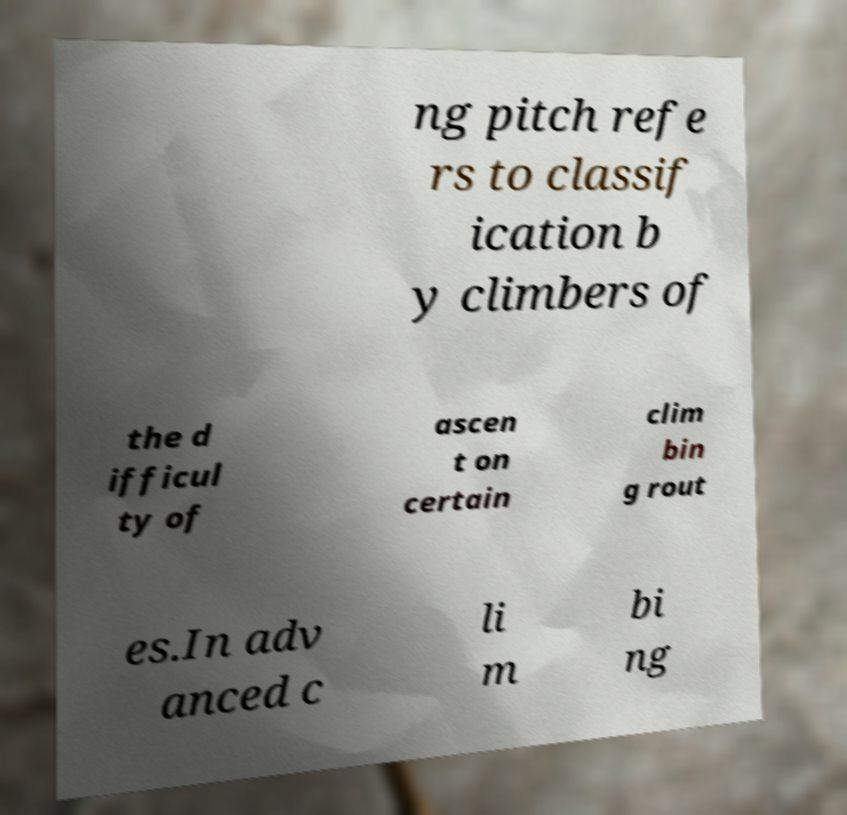Please identify and transcribe the text found in this image. ng pitch refe rs to classif ication b y climbers of the d ifficul ty of ascen t on certain clim bin g rout es.In adv anced c li m bi ng 